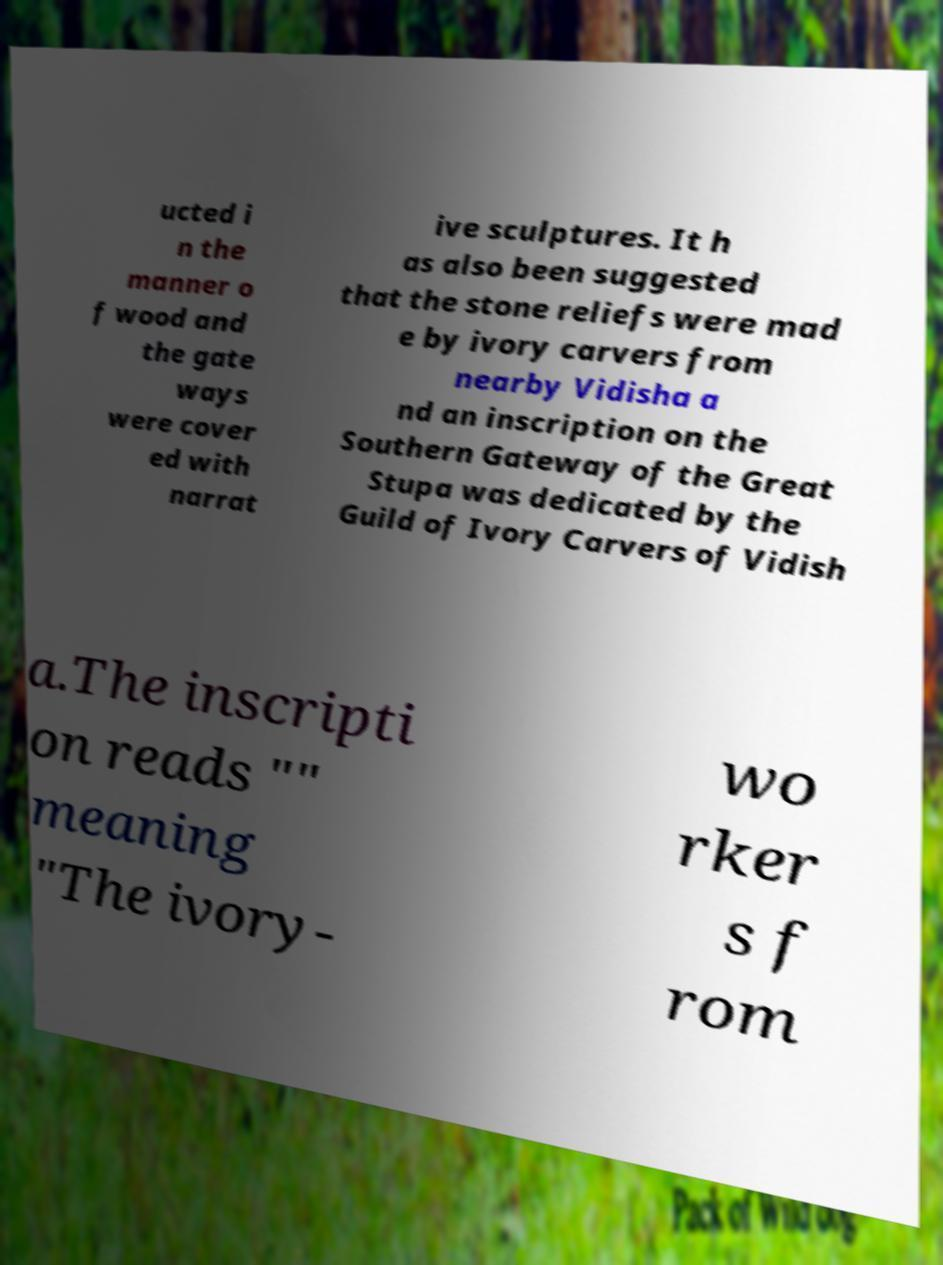There's text embedded in this image that I need extracted. Can you transcribe it verbatim? ucted i n the manner o f wood and the gate ways were cover ed with narrat ive sculptures. It h as also been suggested that the stone reliefs were mad e by ivory carvers from nearby Vidisha a nd an inscription on the Southern Gateway of the Great Stupa was dedicated by the Guild of Ivory Carvers of Vidish a.The inscripti on reads "" meaning "The ivory- wo rker s f rom 